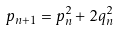Convert formula to latex. <formula><loc_0><loc_0><loc_500><loc_500>p _ { n + 1 } = p _ { n } ^ { 2 } + 2 q _ { n } ^ { 2 }</formula> 